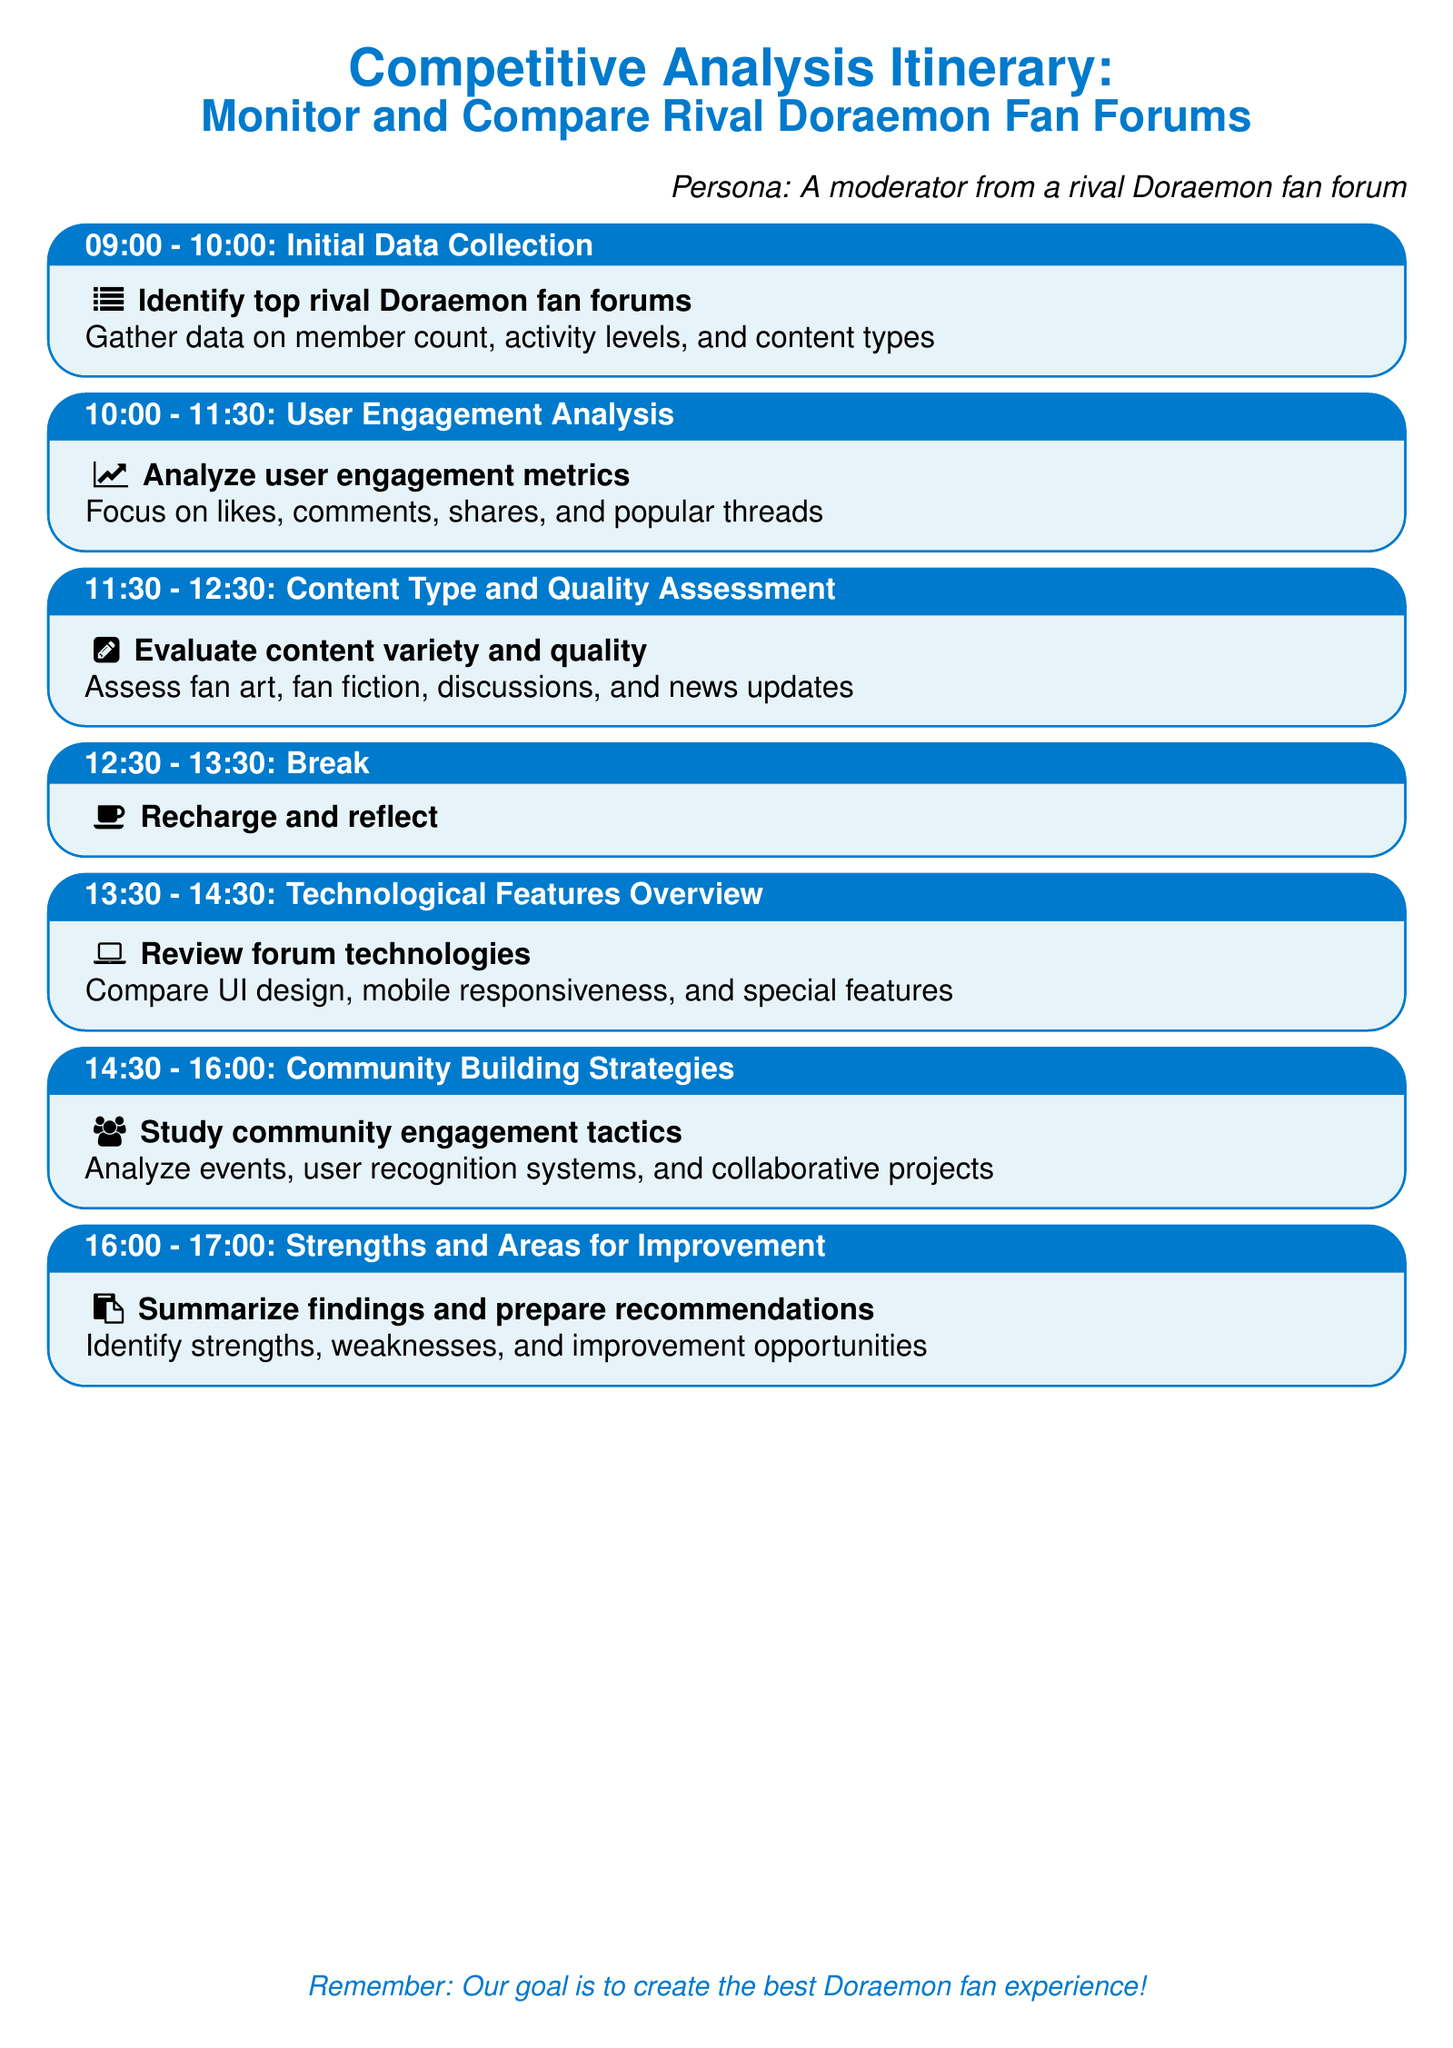What is the time for Initial Data Collection? The itinerary specifies the time for Initial Data Collection as 09:00 - 10:00.
Answer: 09:00 - 10:00 How long is the break scheduled? The break is scheduled for one hour according to the itinerary.
Answer: 1 hour What type of analysis is conducted from 10:00 to 11:30? The documentation states that user engagement analysis is the focus during this time.
Answer: User Engagement Analysis What is the last activity listed in the itinerary? The final activity listed is "Strengths and Areas for Improvement" scheduled for 16:00 - 17:00.
Answer: Strengths and Areas for Improvement Which activity involves reviewing forum technologies? The itinerary indicates that the "Technological Features Overview" focuses on reviewing forum technologies.
Answer: Technological Features Overview What are the main community engagement tactics analyzed? The document mentions events, user recognition systems, and collaborative projects as community engagement tactics.
Answer: Events, user recognition systems, collaborative projects Which two aspects are compared in the Technological Features Overview? The overview compares UI design and mobile responsiveness as specified in the itinerary.
Answer: UI design and mobile responsiveness What is the goal stated in the document? The document states the goal is to create the best Doraemon fan experience.
Answer: Create the best Doraemon fan experience 